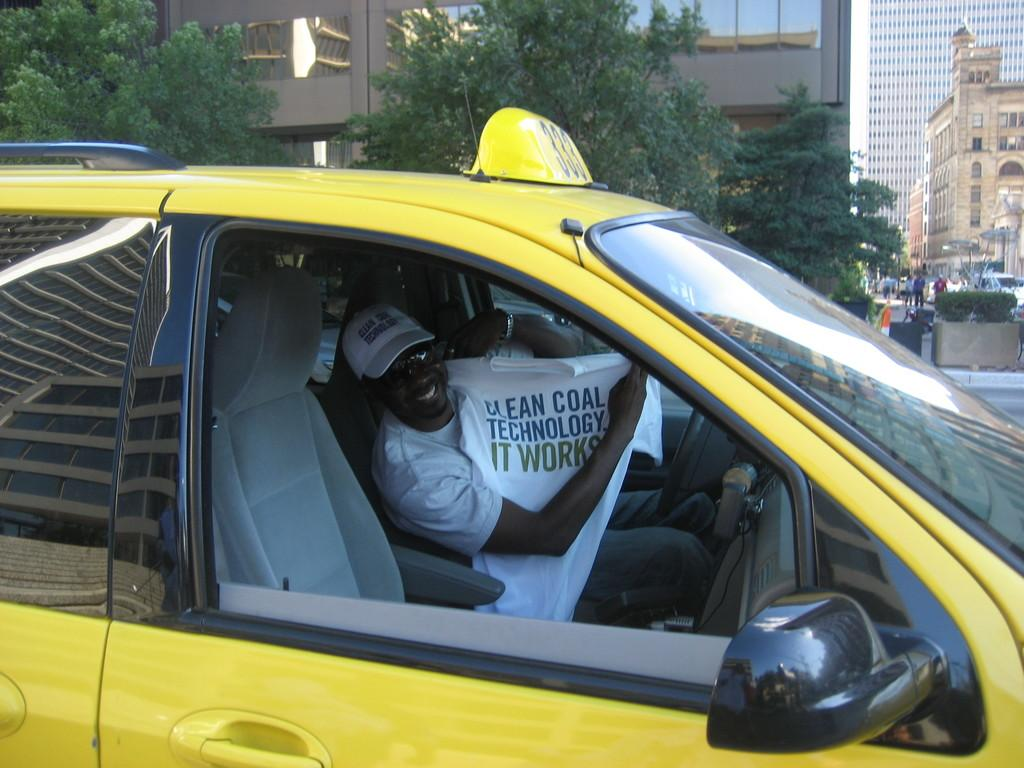Provide a one-sentence caption for the provided image. A taxi driver holds up a t-shirt that reads Clean Coal Technology. 